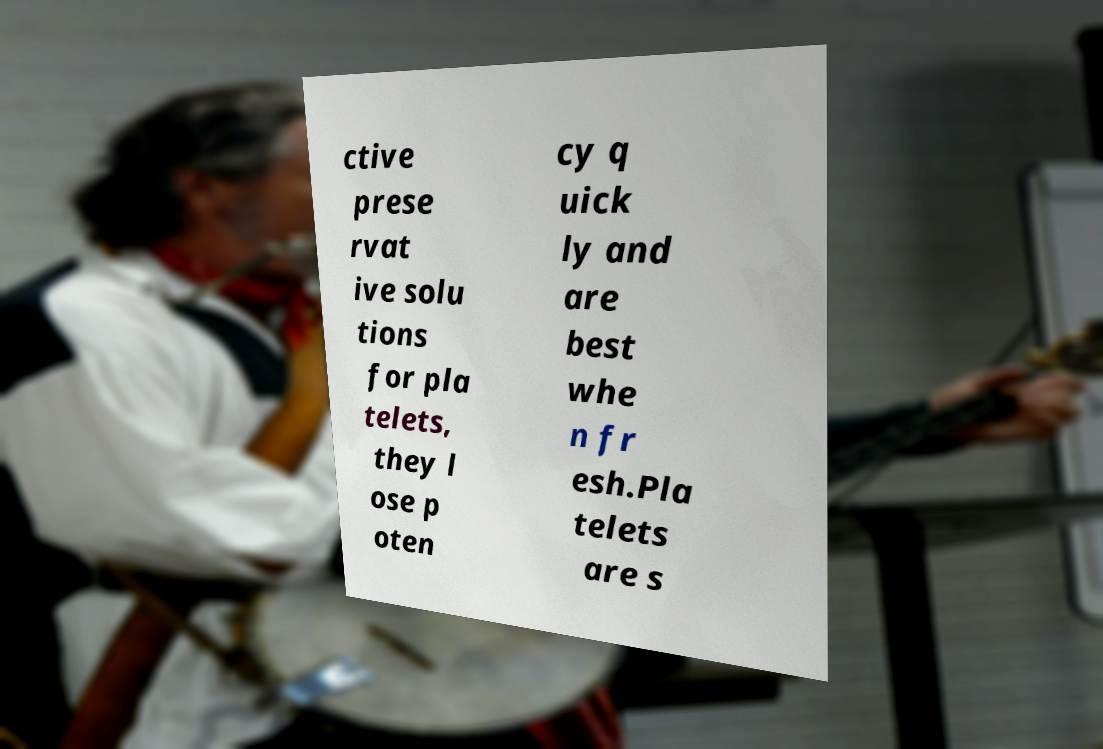Can you accurately transcribe the text from the provided image for me? ctive prese rvat ive solu tions for pla telets, they l ose p oten cy q uick ly and are best whe n fr esh.Pla telets are s 